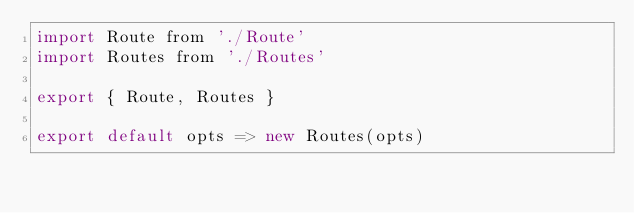Convert code to text. <code><loc_0><loc_0><loc_500><loc_500><_JavaScript_>import Route from './Route'
import Routes from './Routes'

export { Route, Routes }

export default opts => new Routes(opts)
</code> 